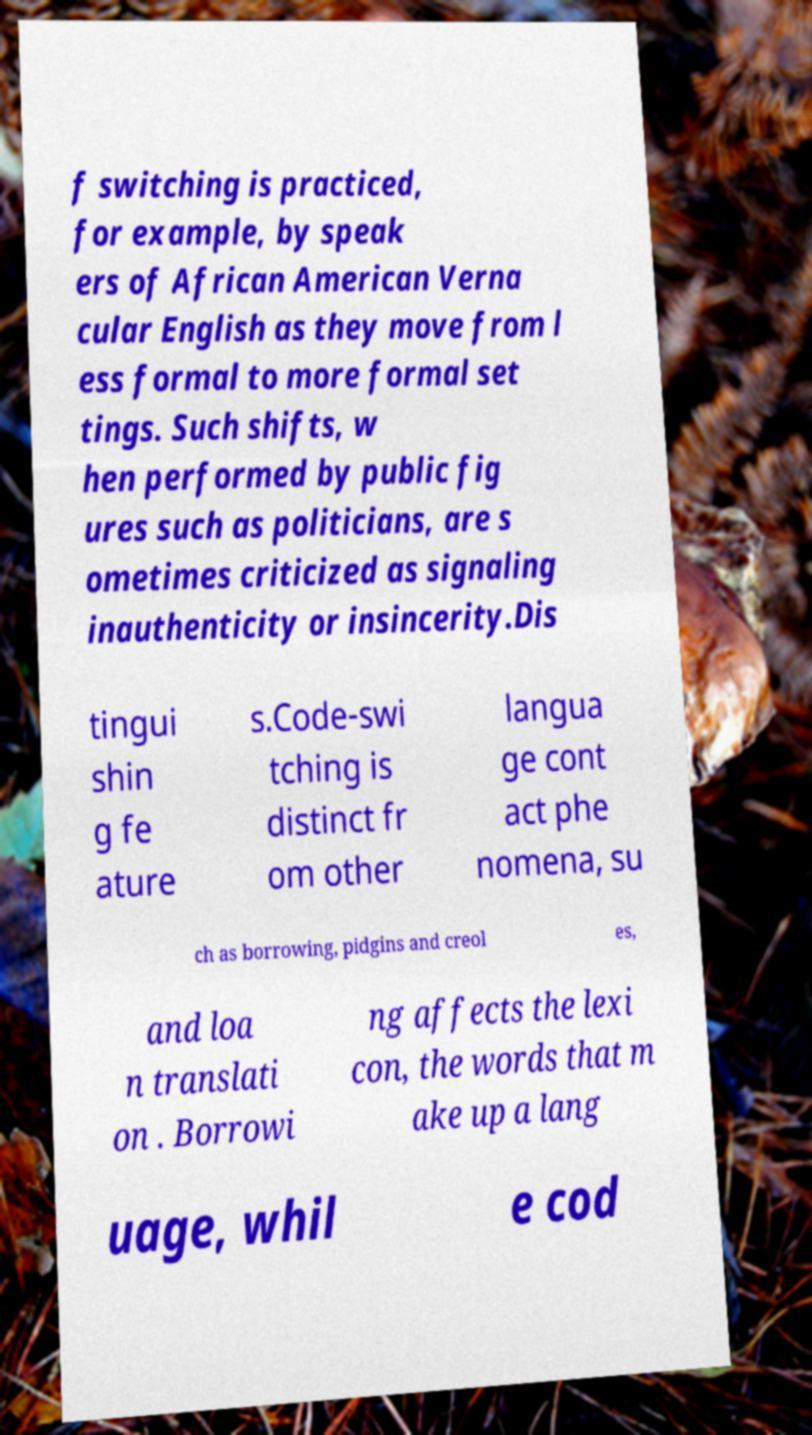Please identify and transcribe the text found in this image. f switching is practiced, for example, by speak ers of African American Verna cular English as they move from l ess formal to more formal set tings. Such shifts, w hen performed by public fig ures such as politicians, are s ometimes criticized as signaling inauthenticity or insincerity.Dis tingui shin g fe ature s.Code-swi tching is distinct fr om other langua ge cont act phe nomena, su ch as borrowing, pidgins and creol es, and loa n translati on . Borrowi ng affects the lexi con, the words that m ake up a lang uage, whil e cod 